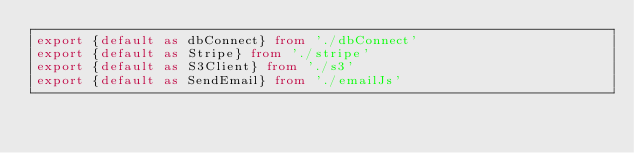Convert code to text. <code><loc_0><loc_0><loc_500><loc_500><_TypeScript_>export {default as dbConnect} from './dbConnect'
export {default as Stripe} from './stripe'
export {default as S3Client} from './s3'
export {default as SendEmail} from './emailJs'
</code> 